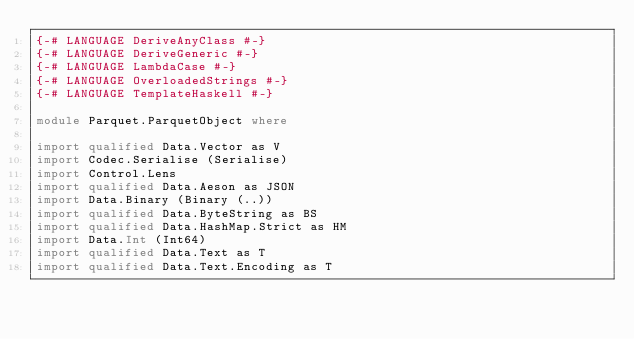Convert code to text. <code><loc_0><loc_0><loc_500><loc_500><_Haskell_>{-# LANGUAGE DeriveAnyClass #-}
{-# LANGUAGE DeriveGeneric #-}
{-# LANGUAGE LambdaCase #-}
{-# LANGUAGE OverloadedStrings #-}
{-# LANGUAGE TemplateHaskell #-}

module Parquet.ParquetObject where

import qualified Data.Vector as V
import Codec.Serialise (Serialise)
import Control.Lens
import qualified Data.Aeson as JSON
import Data.Binary (Binary (..))
import qualified Data.ByteString as BS
import qualified Data.HashMap.Strict as HM
import Data.Int (Int64)
import qualified Data.Text as T
import qualified Data.Text.Encoding as T</code> 